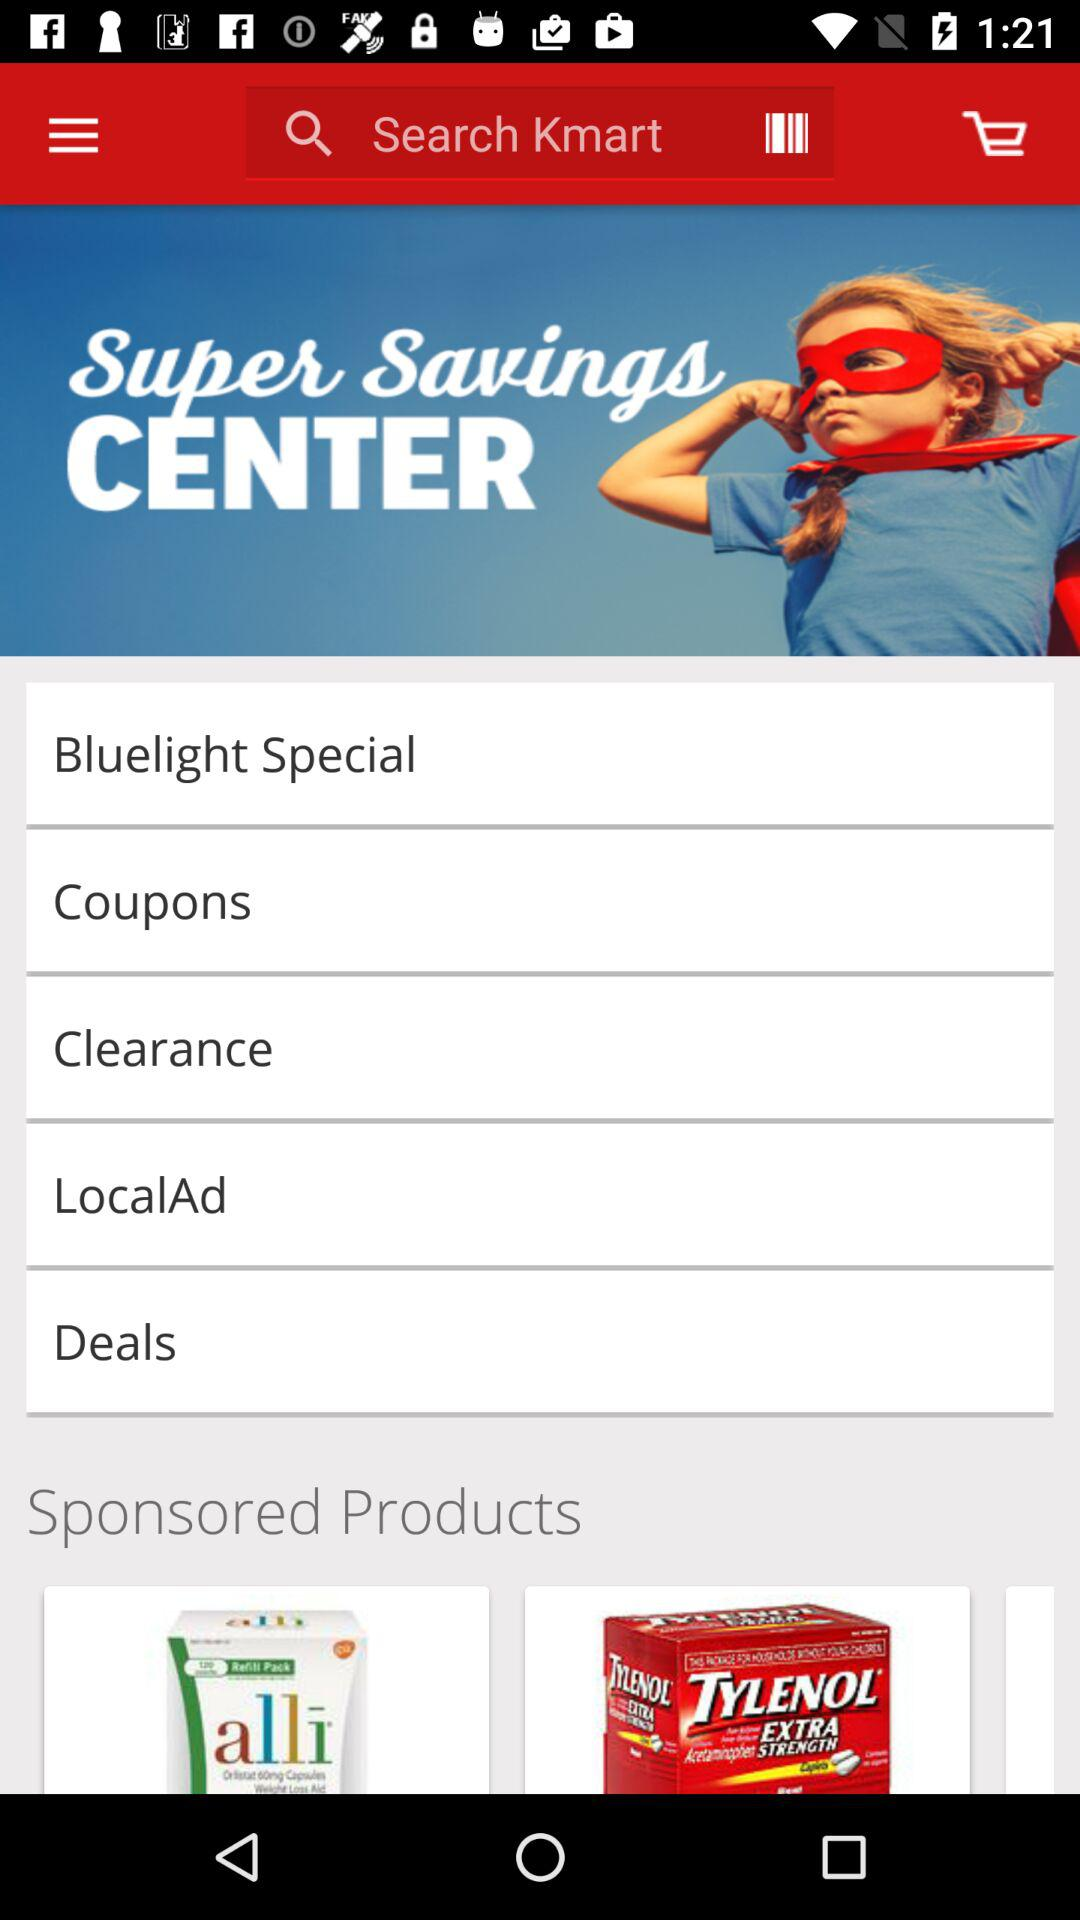What is the application name? The application name is "Super Savings CENTER". 